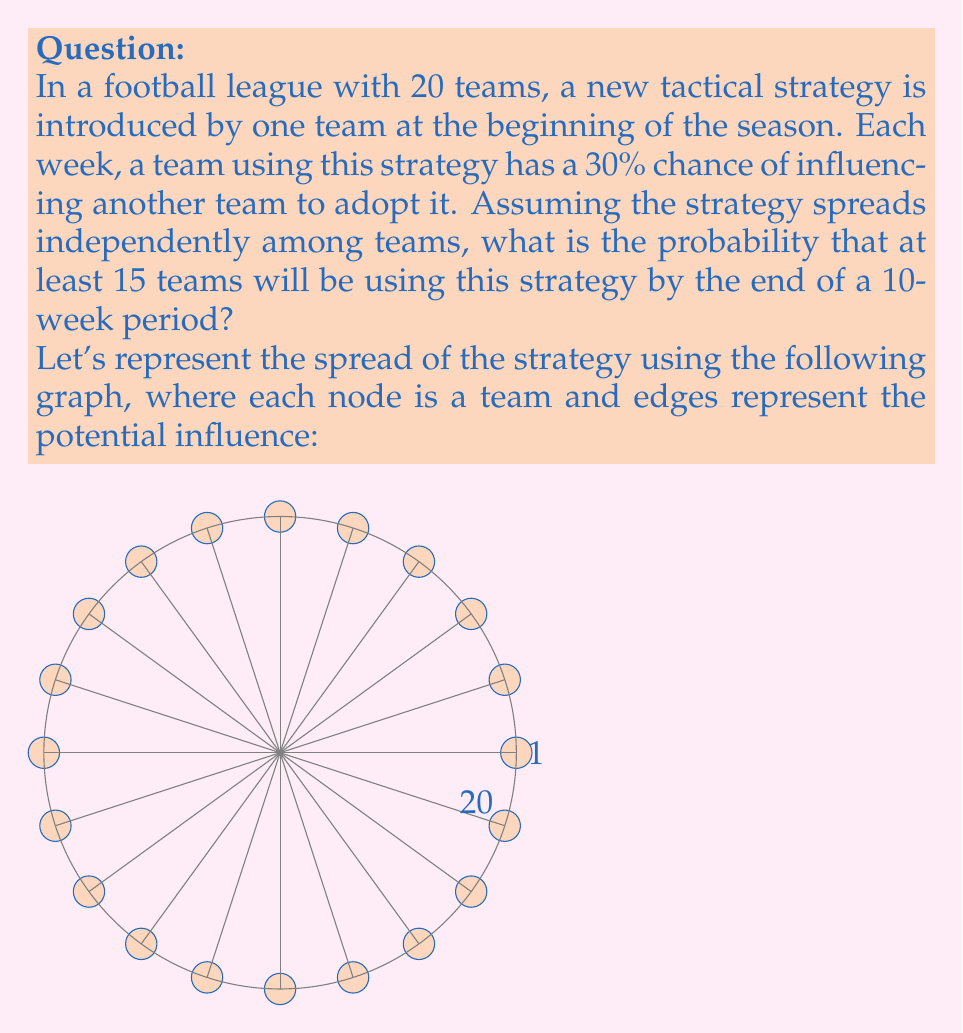Can you answer this question? To solve this problem, we can use the concept of a binomial distribution, as each team's adoption of the strategy can be considered a Bernoulli trial.

1) First, let's calculate the probability of a single team adopting the strategy over the 10-week period:

   $p = 1 - (1 - 0.3)^{10} \approx 0.9718$

2) Now, we have a binomial distribution with $n = 19$ (excluding the initial team) and $p = 0.9718$.

3) We want the probability of 14 or more teams adopting the strategy (to have at least 15 total).

4) The probability is:

   $$P(X \geq 14) = \sum_{k=14}^{19} \binom{19}{k} p^k (1-p)^{19-k}$$

5) Using a calculator or computer, we can compute this sum:

   $$P(X \geq 14) \approx 0.9997$$

Therefore, the probability that at least 15 teams (including the initial team) will be using the strategy by the end of the 10-week period is approximately 0.9997 or 99.97%.
Answer: 0.9997 